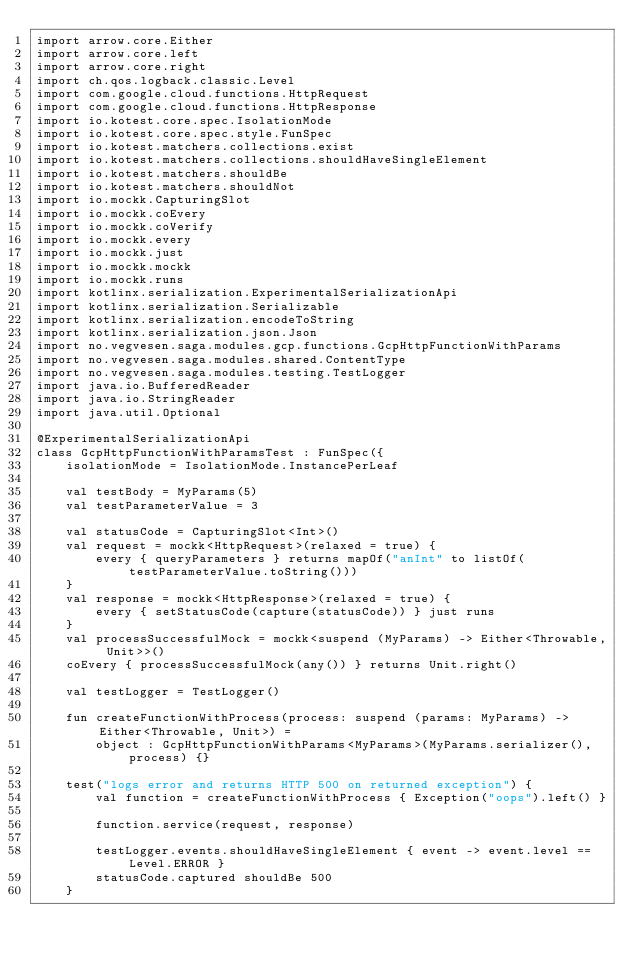Convert code to text. <code><loc_0><loc_0><loc_500><loc_500><_Kotlin_>import arrow.core.Either
import arrow.core.left
import arrow.core.right
import ch.qos.logback.classic.Level
import com.google.cloud.functions.HttpRequest
import com.google.cloud.functions.HttpResponse
import io.kotest.core.spec.IsolationMode
import io.kotest.core.spec.style.FunSpec
import io.kotest.matchers.collections.exist
import io.kotest.matchers.collections.shouldHaveSingleElement
import io.kotest.matchers.shouldBe
import io.kotest.matchers.shouldNot
import io.mockk.CapturingSlot
import io.mockk.coEvery
import io.mockk.coVerify
import io.mockk.every
import io.mockk.just
import io.mockk.mockk
import io.mockk.runs
import kotlinx.serialization.ExperimentalSerializationApi
import kotlinx.serialization.Serializable
import kotlinx.serialization.encodeToString
import kotlinx.serialization.json.Json
import no.vegvesen.saga.modules.gcp.functions.GcpHttpFunctionWithParams
import no.vegvesen.saga.modules.shared.ContentType
import no.vegvesen.saga.modules.testing.TestLogger
import java.io.BufferedReader
import java.io.StringReader
import java.util.Optional

@ExperimentalSerializationApi
class GcpHttpFunctionWithParamsTest : FunSpec({
    isolationMode = IsolationMode.InstancePerLeaf

    val testBody = MyParams(5)
    val testParameterValue = 3

    val statusCode = CapturingSlot<Int>()
    val request = mockk<HttpRequest>(relaxed = true) {
        every { queryParameters } returns mapOf("anInt" to listOf(testParameterValue.toString()))
    }
    val response = mockk<HttpResponse>(relaxed = true) {
        every { setStatusCode(capture(statusCode)) } just runs
    }
    val processSuccessfulMock = mockk<suspend (MyParams) -> Either<Throwable, Unit>>()
    coEvery { processSuccessfulMock(any()) } returns Unit.right()

    val testLogger = TestLogger()

    fun createFunctionWithProcess(process: suspend (params: MyParams) -> Either<Throwable, Unit>) =
        object : GcpHttpFunctionWithParams<MyParams>(MyParams.serializer(), process) {}

    test("logs error and returns HTTP 500 on returned exception") {
        val function = createFunctionWithProcess { Exception("oops").left() }

        function.service(request, response)

        testLogger.events.shouldHaveSingleElement { event -> event.level == Level.ERROR }
        statusCode.captured shouldBe 500
    }
</code> 